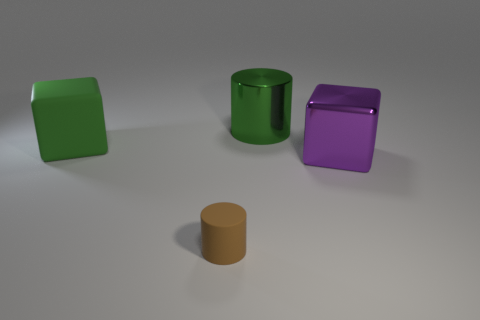Are there any tiny cylinders? yes 